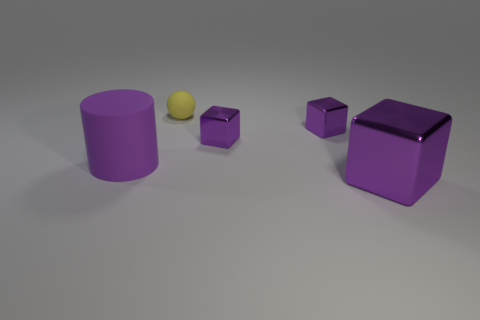Could you estimate the sizes of these objects relative to each other? Certainly, the cylinder and the larger cube seem to be approximately the same height, while the two smaller cubes are of equal size and appear to be roughly half the height of the larger cube and cylinder. The yellow sphere is the smallest object. 